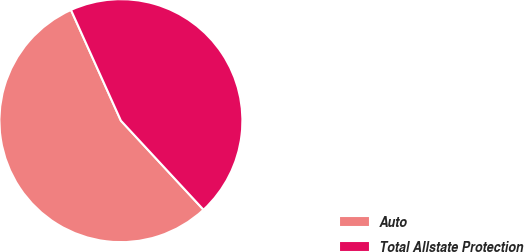Convert chart. <chart><loc_0><loc_0><loc_500><loc_500><pie_chart><fcel>Auto<fcel>Total Allstate Protection<nl><fcel>55.16%<fcel>44.84%<nl></chart> 